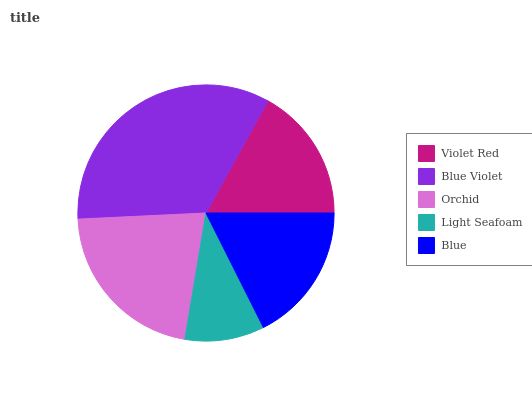Is Light Seafoam the minimum?
Answer yes or no. Yes. Is Blue Violet the maximum?
Answer yes or no. Yes. Is Orchid the minimum?
Answer yes or no. No. Is Orchid the maximum?
Answer yes or no. No. Is Blue Violet greater than Orchid?
Answer yes or no. Yes. Is Orchid less than Blue Violet?
Answer yes or no. Yes. Is Orchid greater than Blue Violet?
Answer yes or no. No. Is Blue Violet less than Orchid?
Answer yes or no. No. Is Blue the high median?
Answer yes or no. Yes. Is Blue the low median?
Answer yes or no. Yes. Is Blue Violet the high median?
Answer yes or no. No. Is Violet Red the low median?
Answer yes or no. No. 